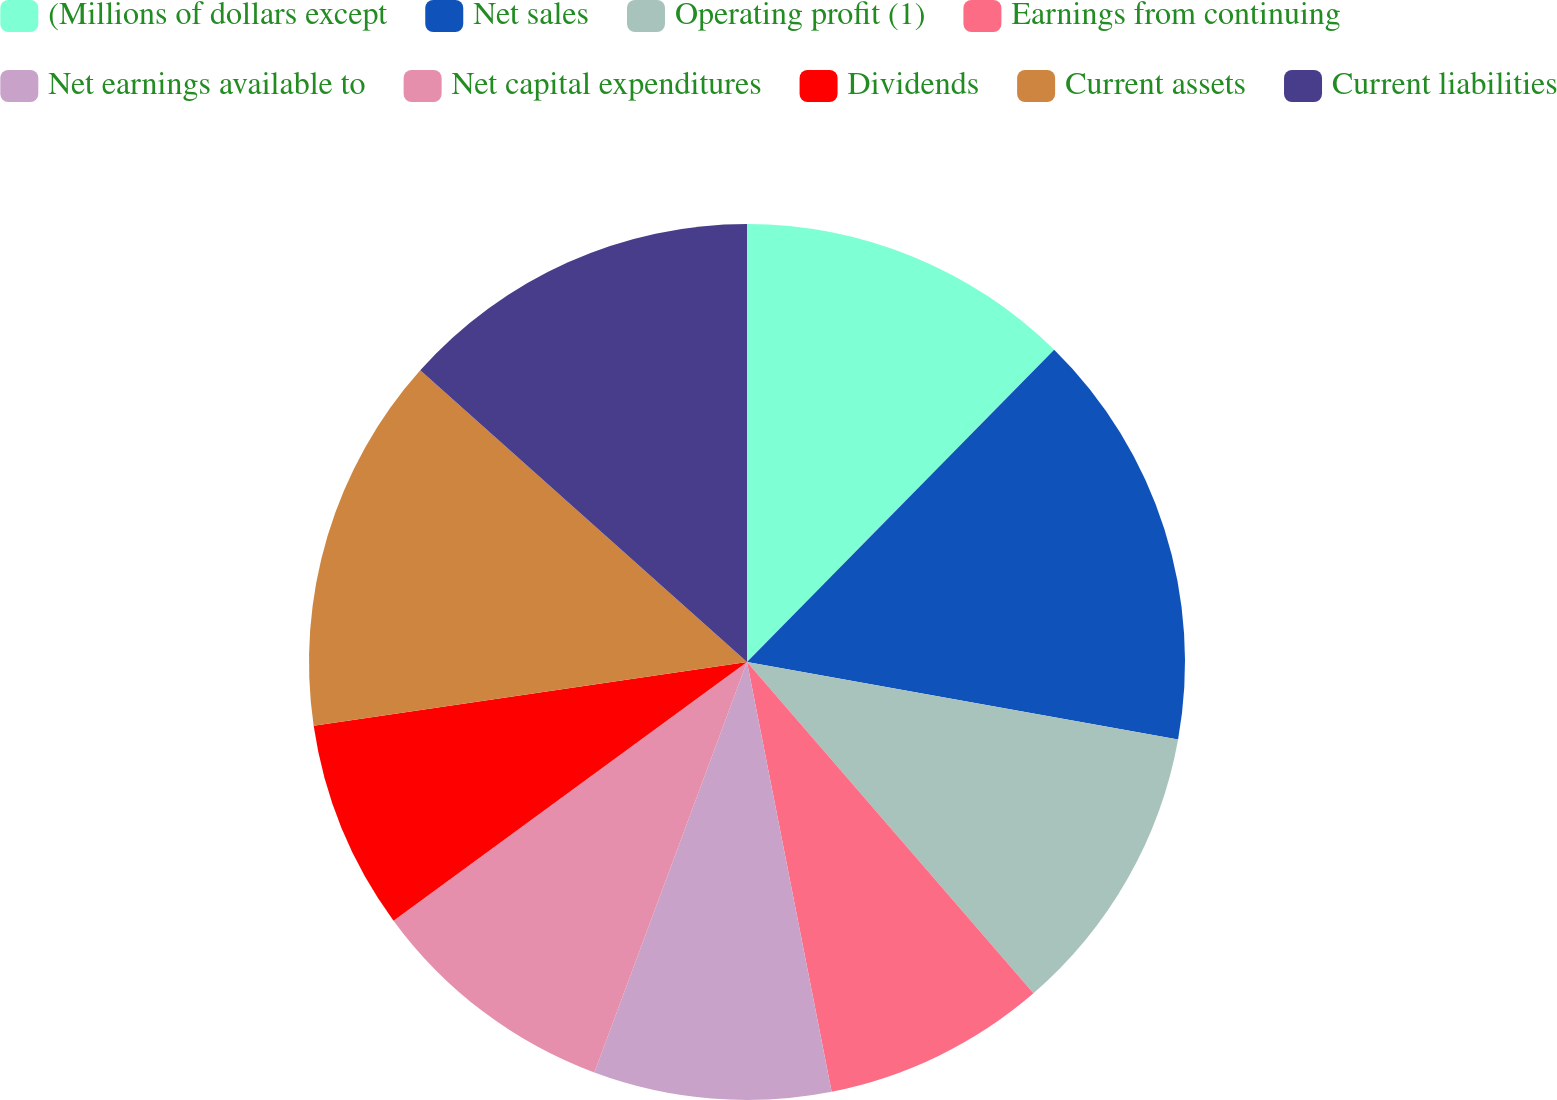Convert chart to OTSL. <chart><loc_0><loc_0><loc_500><loc_500><pie_chart><fcel>(Millions of dollars except<fcel>Net sales<fcel>Operating profit (1)<fcel>Earnings from continuing<fcel>Net earnings available to<fcel>Net capital expenditures<fcel>Dividends<fcel>Current assets<fcel>Current liabilities<nl><fcel>12.37%<fcel>15.46%<fcel>10.82%<fcel>8.25%<fcel>8.76%<fcel>9.28%<fcel>7.73%<fcel>13.92%<fcel>13.4%<nl></chart> 